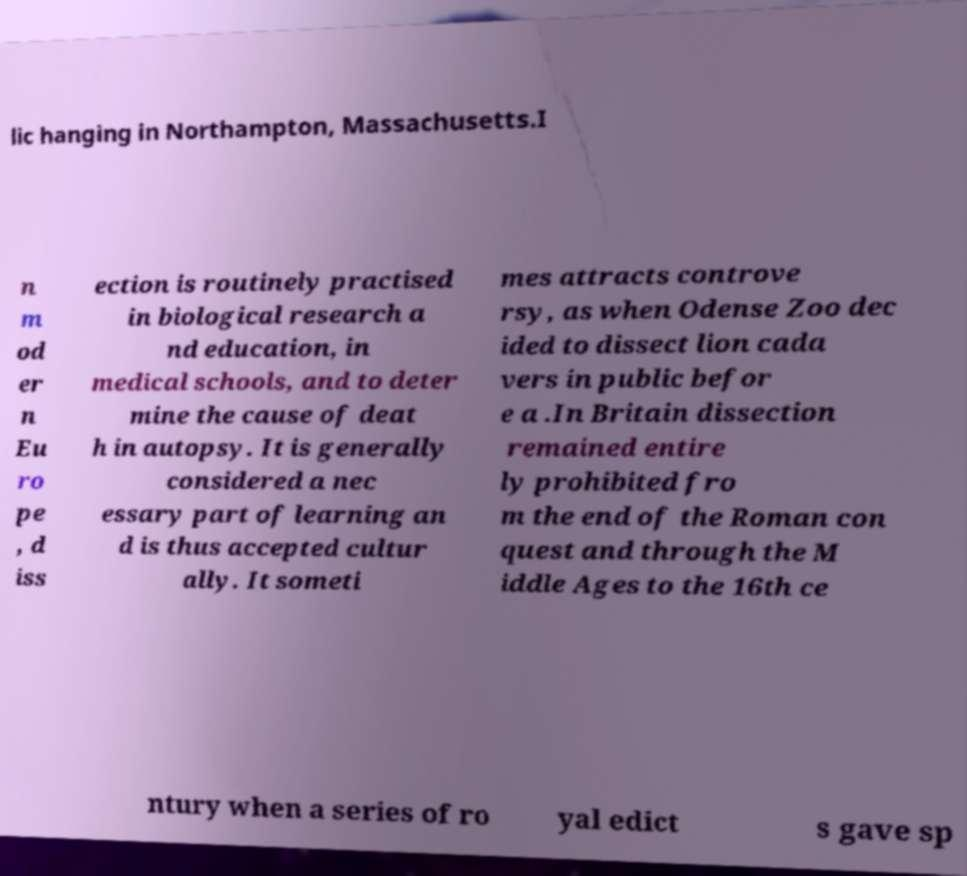Could you extract and type out the text from this image? lic hanging in Northampton, Massachusetts.I n m od er n Eu ro pe , d iss ection is routinely practised in biological research a nd education, in medical schools, and to deter mine the cause of deat h in autopsy. It is generally considered a nec essary part of learning an d is thus accepted cultur ally. It someti mes attracts controve rsy, as when Odense Zoo dec ided to dissect lion cada vers in public befor e a .In Britain dissection remained entire ly prohibited fro m the end of the Roman con quest and through the M iddle Ages to the 16th ce ntury when a series of ro yal edict s gave sp 